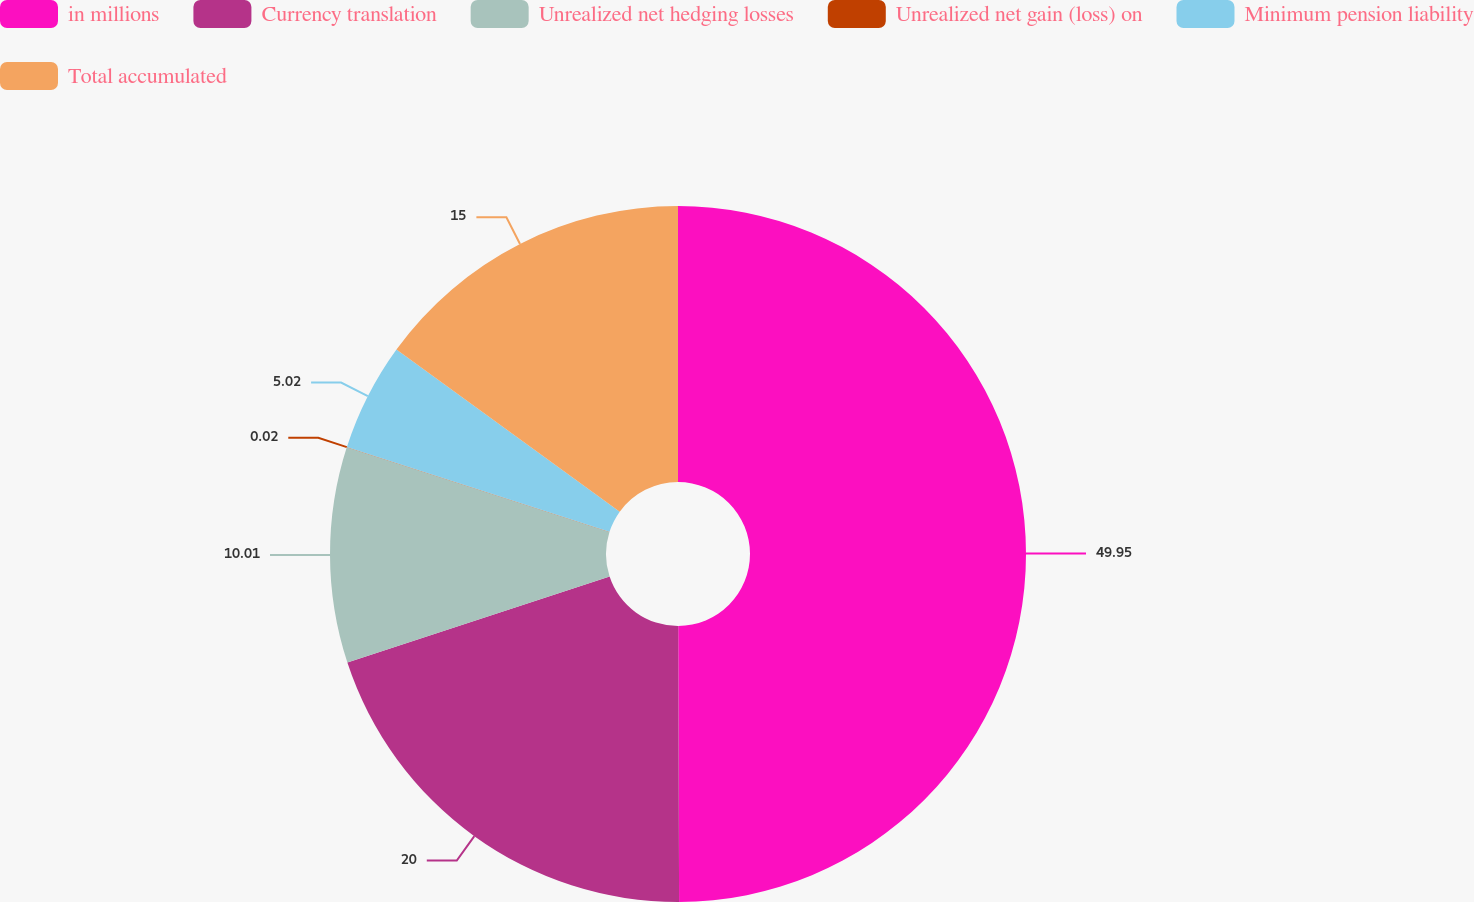Convert chart to OTSL. <chart><loc_0><loc_0><loc_500><loc_500><pie_chart><fcel>in millions<fcel>Currency translation<fcel>Unrealized net hedging losses<fcel>Unrealized net gain (loss) on<fcel>Minimum pension liability<fcel>Total accumulated<nl><fcel>49.95%<fcel>20.0%<fcel>10.01%<fcel>0.02%<fcel>5.02%<fcel>15.0%<nl></chart> 